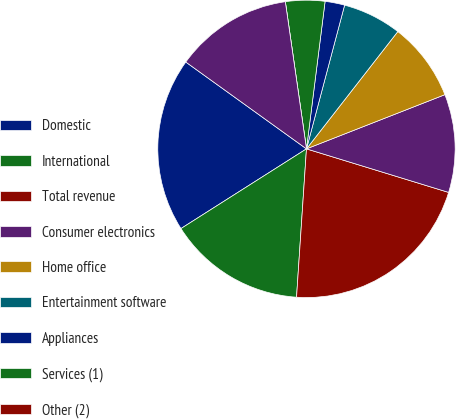<chart> <loc_0><loc_0><loc_500><loc_500><pie_chart><fcel>Domestic<fcel>International<fcel>Total revenue<fcel>Consumer electronics<fcel>Home office<fcel>Entertainment software<fcel>Appliances<fcel>Services (1)<fcel>Other (2)<fcel>Total<nl><fcel>18.93%<fcel>14.93%<fcel>21.33%<fcel>10.67%<fcel>8.53%<fcel>6.4%<fcel>2.13%<fcel>4.27%<fcel>0.0%<fcel>12.8%<nl></chart> 